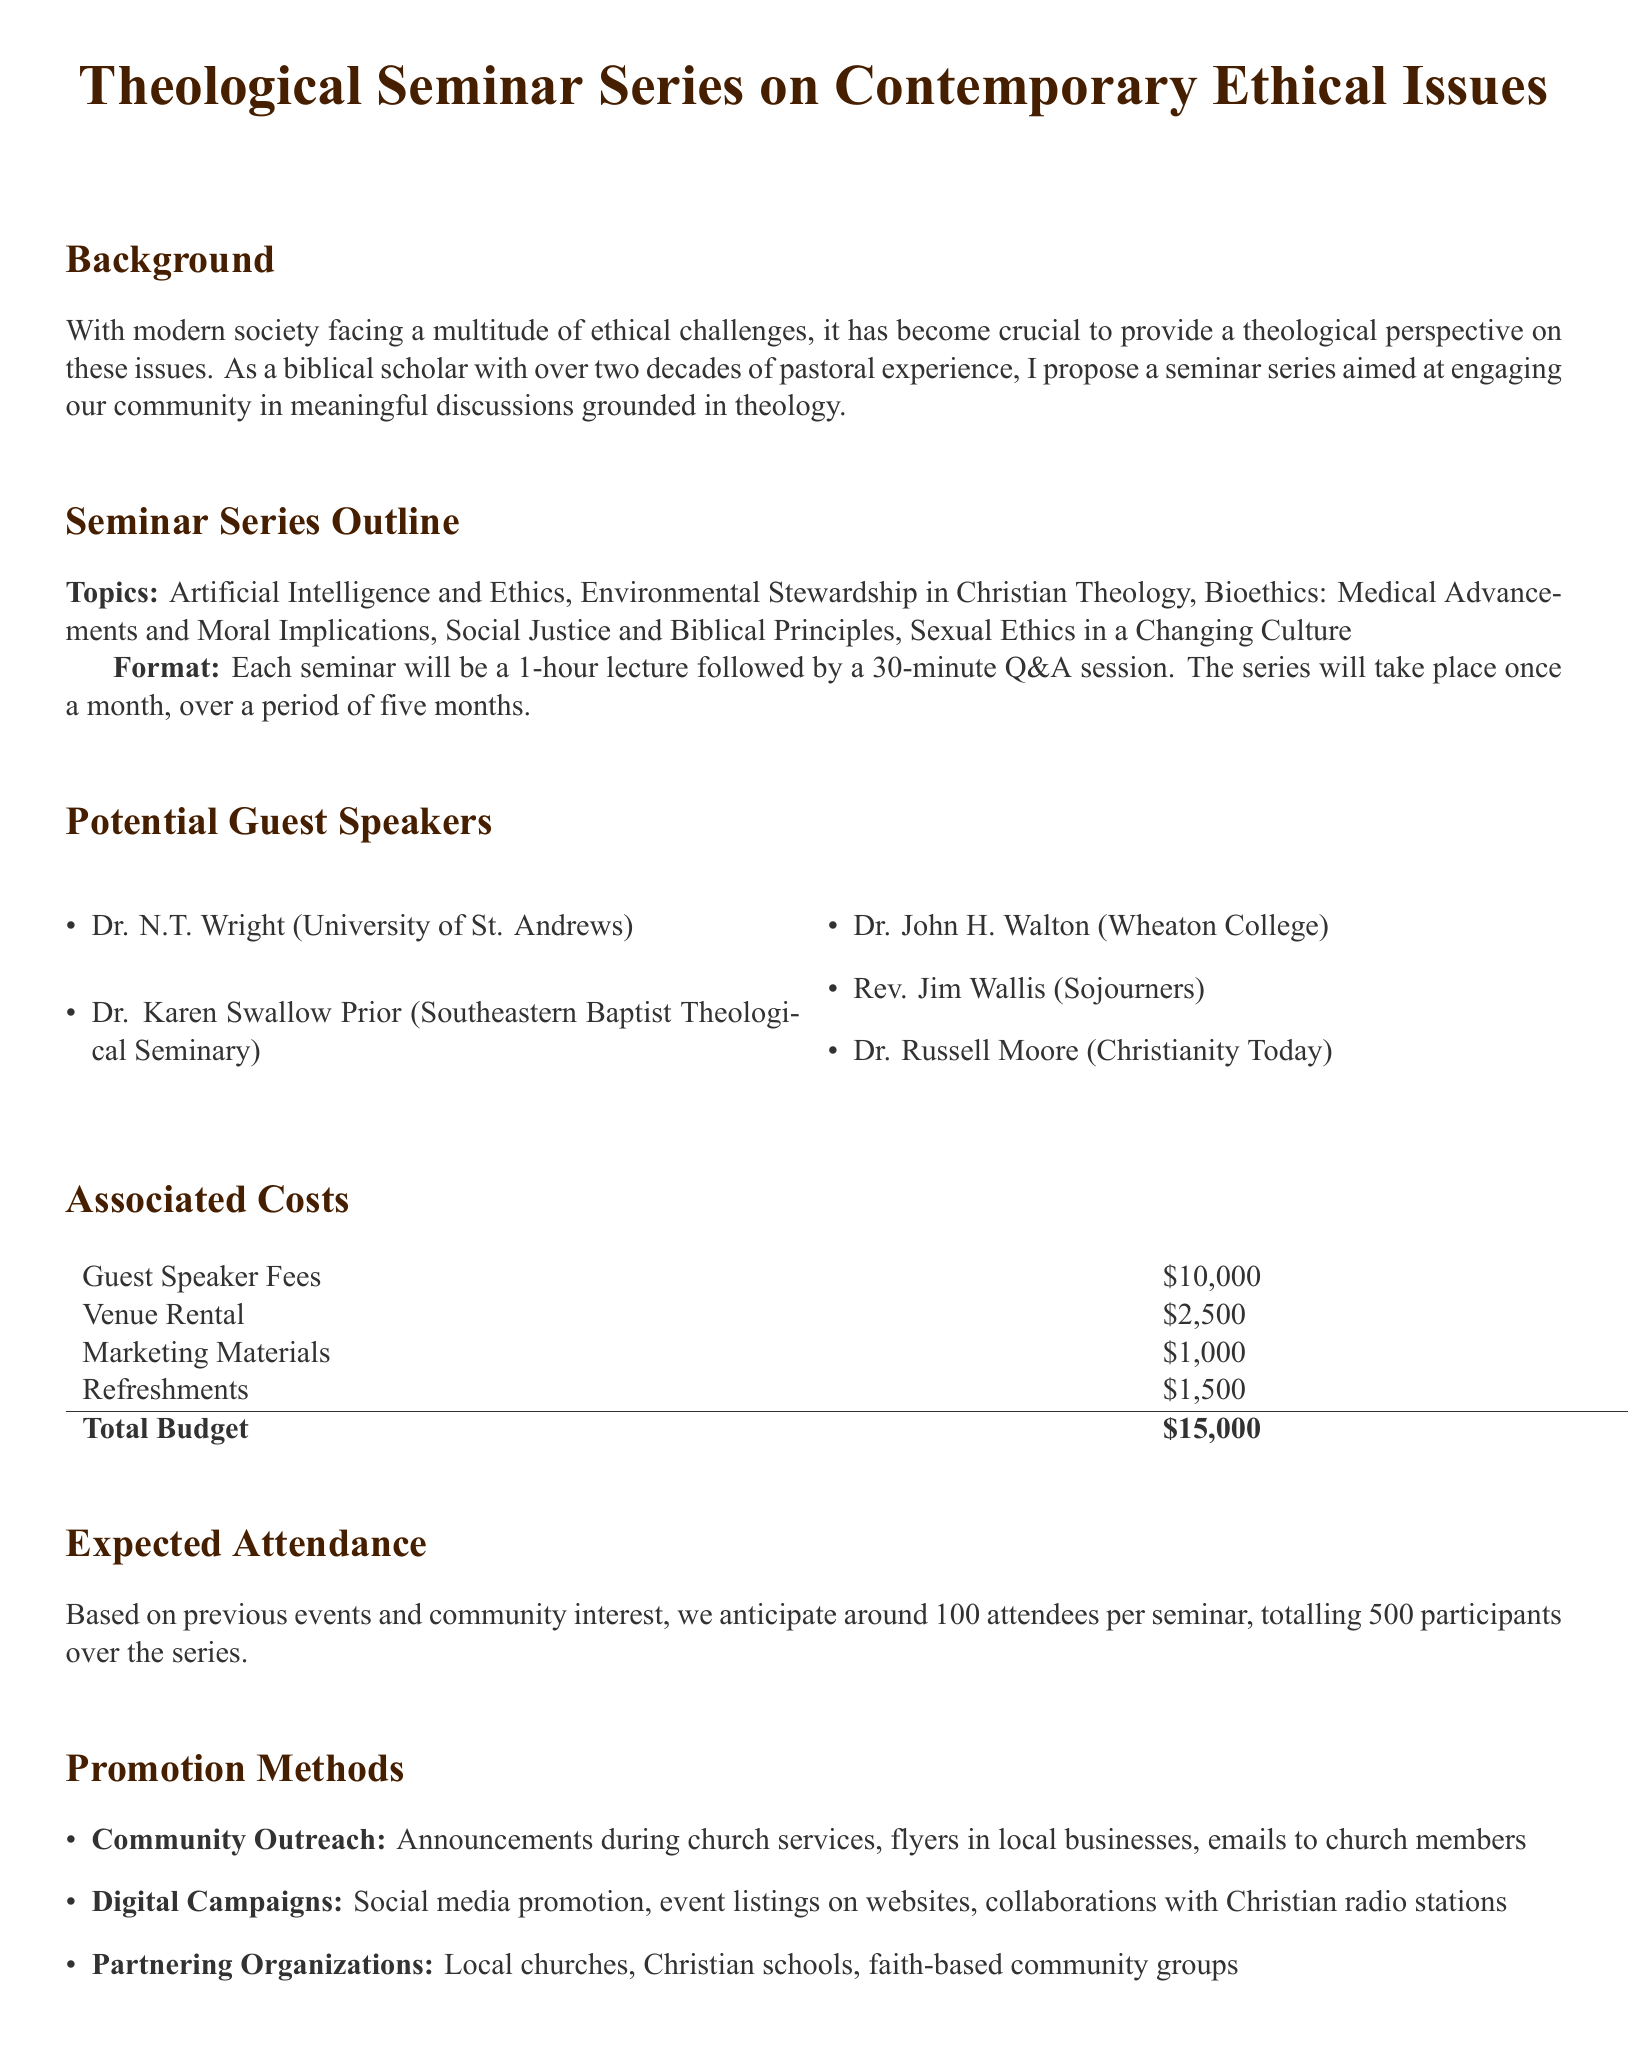what is the total budget for the seminar series? The total budget is stated in the document as the sum of various associated costs, which comes to $15,000.
Answer: $15,000 who is the guest speaker from Sojourners? The document lists Rev. Jim Wallis as the guest speaker associated with Sojourners.
Answer: Rev. Jim Wallis how many months will the seminar series run? The proposal specifies that the seminar series will take place once a month, over a period of five months.
Answer: five months which ethical topic involves advancements in medicine? One of the seminar topics specifically addresses moral implications related to medical advancements, which can be identified as Bioethics.
Answer: Bioethics what marketing strategy includes email communication? The document mentions community outreach as a method that involves emails to church members for promoting the events.
Answer: Community Outreach what is the expected number of attendees for each seminar? The proposal indicates an anticipated attendance of around 100 attendees per seminar, totaling 500 over the series.
Answer: 100 attendees who is the guest speaker from Wheaton College? Dr. John H. Walton is identified as the guest speaker from Wheaton College in the document.
Answer: Dr. John H. Walton what is one method of digital promotion mentioned? The document lists social media promotion as part of the digital campaign for promoting the seminar series.
Answer: Social media promotion what topic relates to climate issues? Environmental Stewardship in Christian Theology is the topic that relates to climate issues among the seminar topics outlined.
Answer: Environmental Stewardship in Christian Theology 